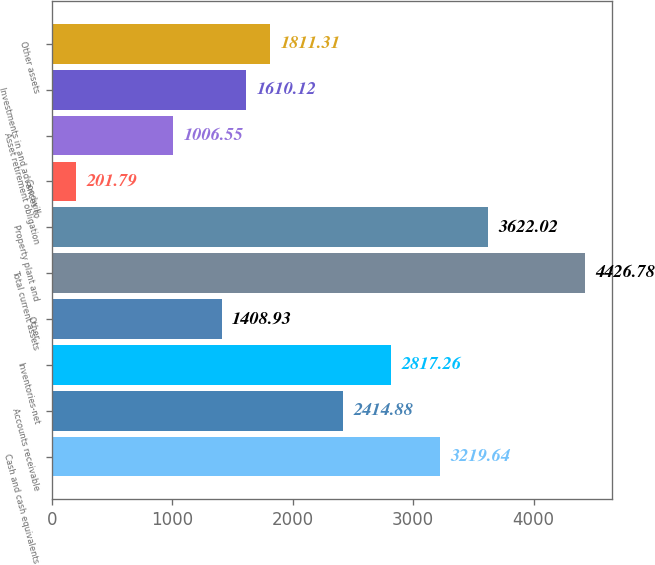Convert chart to OTSL. <chart><loc_0><loc_0><loc_500><loc_500><bar_chart><fcel>Cash and cash equivalents<fcel>Accounts receivable<fcel>Inventories-net<fcel>Other<fcel>Total current assets<fcel>Property plant and<fcel>Goodwill<fcel>Asset retirement obligation<fcel>Investments in and advances to<fcel>Other assets<nl><fcel>3219.64<fcel>2414.88<fcel>2817.26<fcel>1408.93<fcel>4426.78<fcel>3622.02<fcel>201.79<fcel>1006.55<fcel>1610.12<fcel>1811.31<nl></chart> 